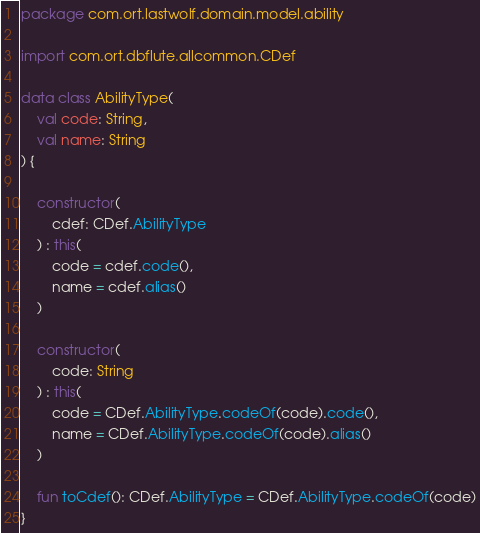<code> <loc_0><loc_0><loc_500><loc_500><_Kotlin_>package com.ort.lastwolf.domain.model.ability

import com.ort.dbflute.allcommon.CDef

data class AbilityType(
    val code: String,
    val name: String
) {

    constructor(
        cdef: CDef.AbilityType
    ) : this(
        code = cdef.code(),
        name = cdef.alias()
    )

    constructor(
        code: String
    ) : this(
        code = CDef.AbilityType.codeOf(code).code(),
        name = CDef.AbilityType.codeOf(code).alias()
    )

    fun toCdef(): CDef.AbilityType = CDef.AbilityType.codeOf(code)
}</code> 